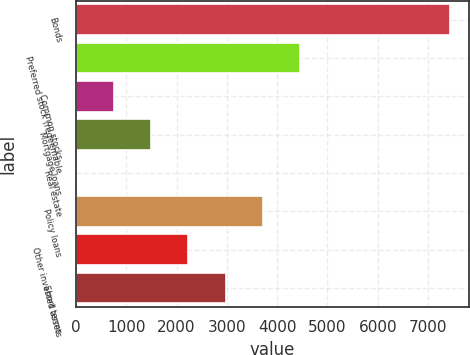Convert chart to OTSL. <chart><loc_0><loc_0><loc_500><loc_500><bar_chart><fcel>Bonds<fcel>Preferred stock (redeemable<fcel>Common stocks<fcel>Mortgage loans<fcel>Real estate<fcel>Policy loans<fcel>Other invested assets<fcel>Short terms<nl><fcel>7435<fcel>4464.2<fcel>750.7<fcel>1493.4<fcel>8<fcel>3721.5<fcel>2236.1<fcel>2978.8<nl></chart> 